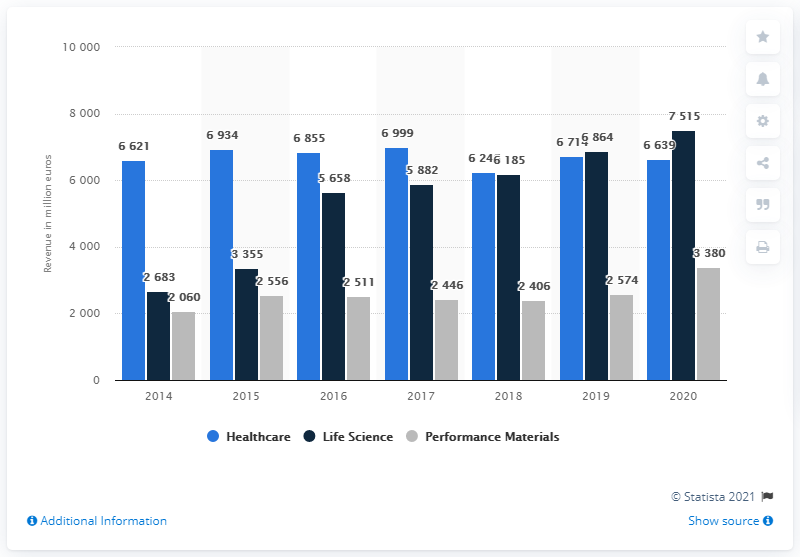Identify some key points in this picture. In 2018, Merck generated the most revenue from the healthcare industry. In 2020, Merck experienced a significant increase in revenue from its life science division compared to its healthcare division. Specifically, the life science division generated approximately 876 more units of revenue than the healthcare division. Merck KGaA's healthcare division generated approximately 6,621 million euros in revenue in 2020. 